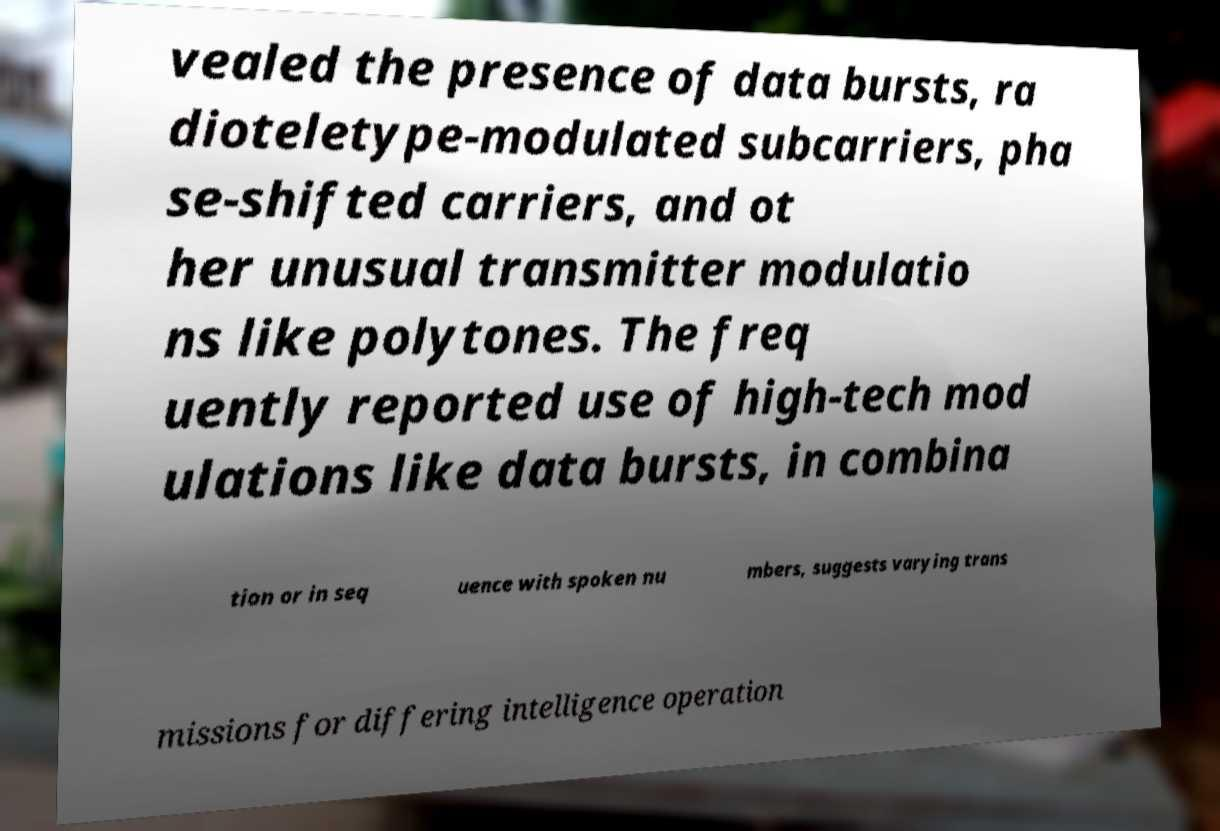What messages or text are displayed in this image? I need them in a readable, typed format. vealed the presence of data bursts, ra dioteletype-modulated subcarriers, pha se-shifted carriers, and ot her unusual transmitter modulatio ns like polytones. The freq uently reported use of high-tech mod ulations like data bursts, in combina tion or in seq uence with spoken nu mbers, suggests varying trans missions for differing intelligence operation 